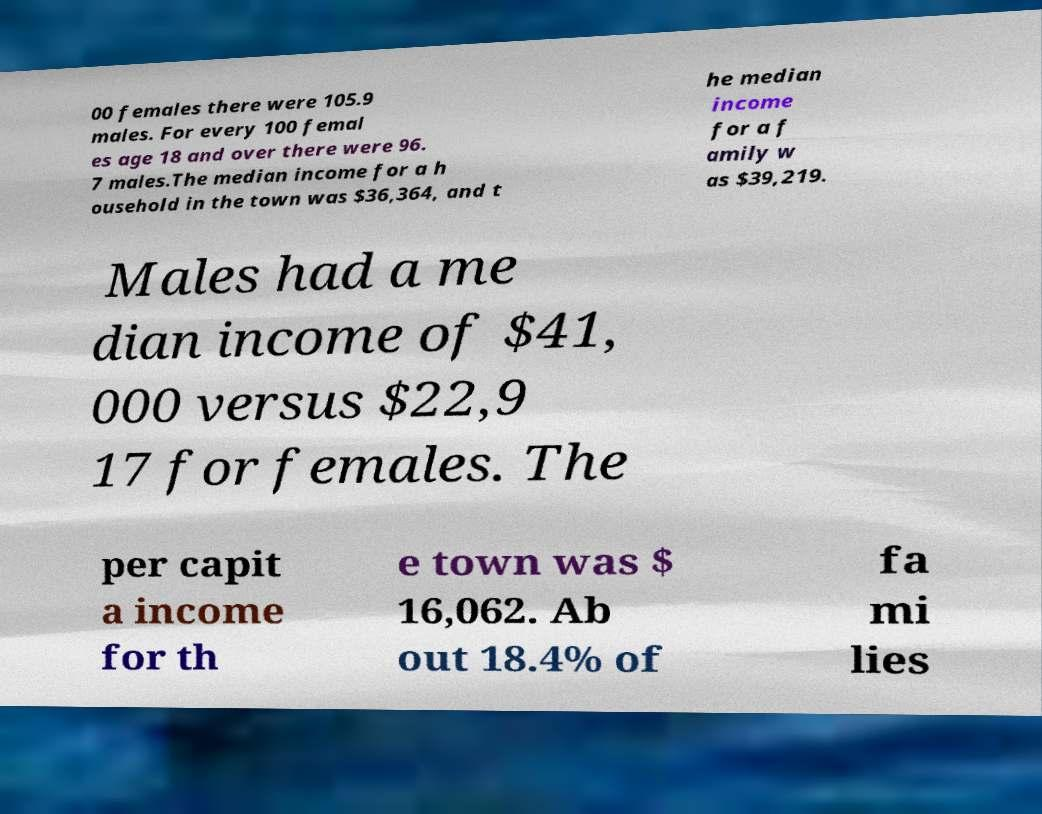Could you extract and type out the text from this image? 00 females there were 105.9 males. For every 100 femal es age 18 and over there were 96. 7 males.The median income for a h ousehold in the town was $36,364, and t he median income for a f amily w as $39,219. Males had a me dian income of $41, 000 versus $22,9 17 for females. The per capit a income for th e town was $ 16,062. Ab out 18.4% of fa mi lies 